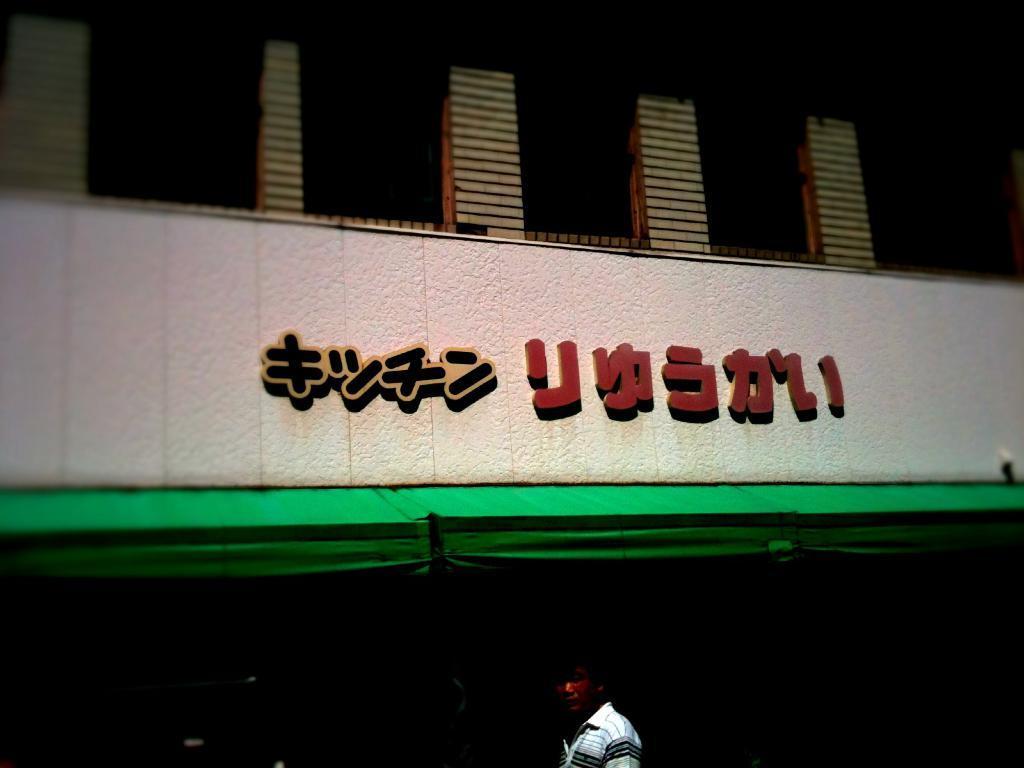In one or two sentences, can you explain what this image depicts? In this image we can see a person standing at the bottom of the image. In the background, we can see a building and there is some text on the wall. 